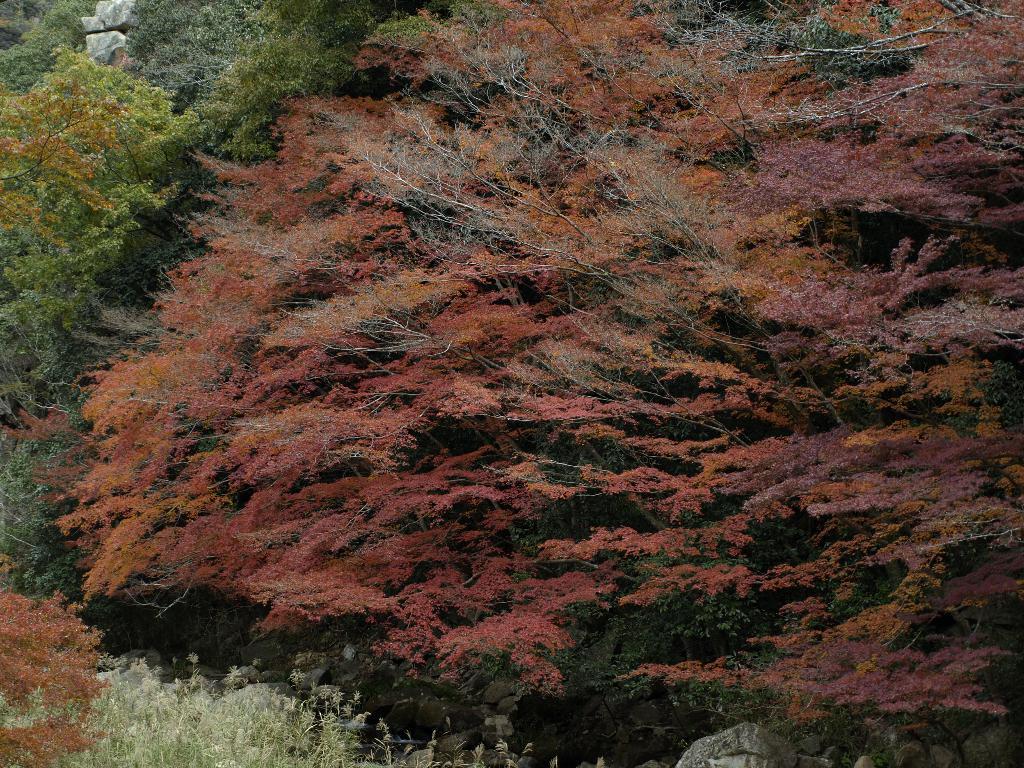In one or two sentences, can you explain what this image depicts? In this image we can see some trees, plants, and the rocks. 